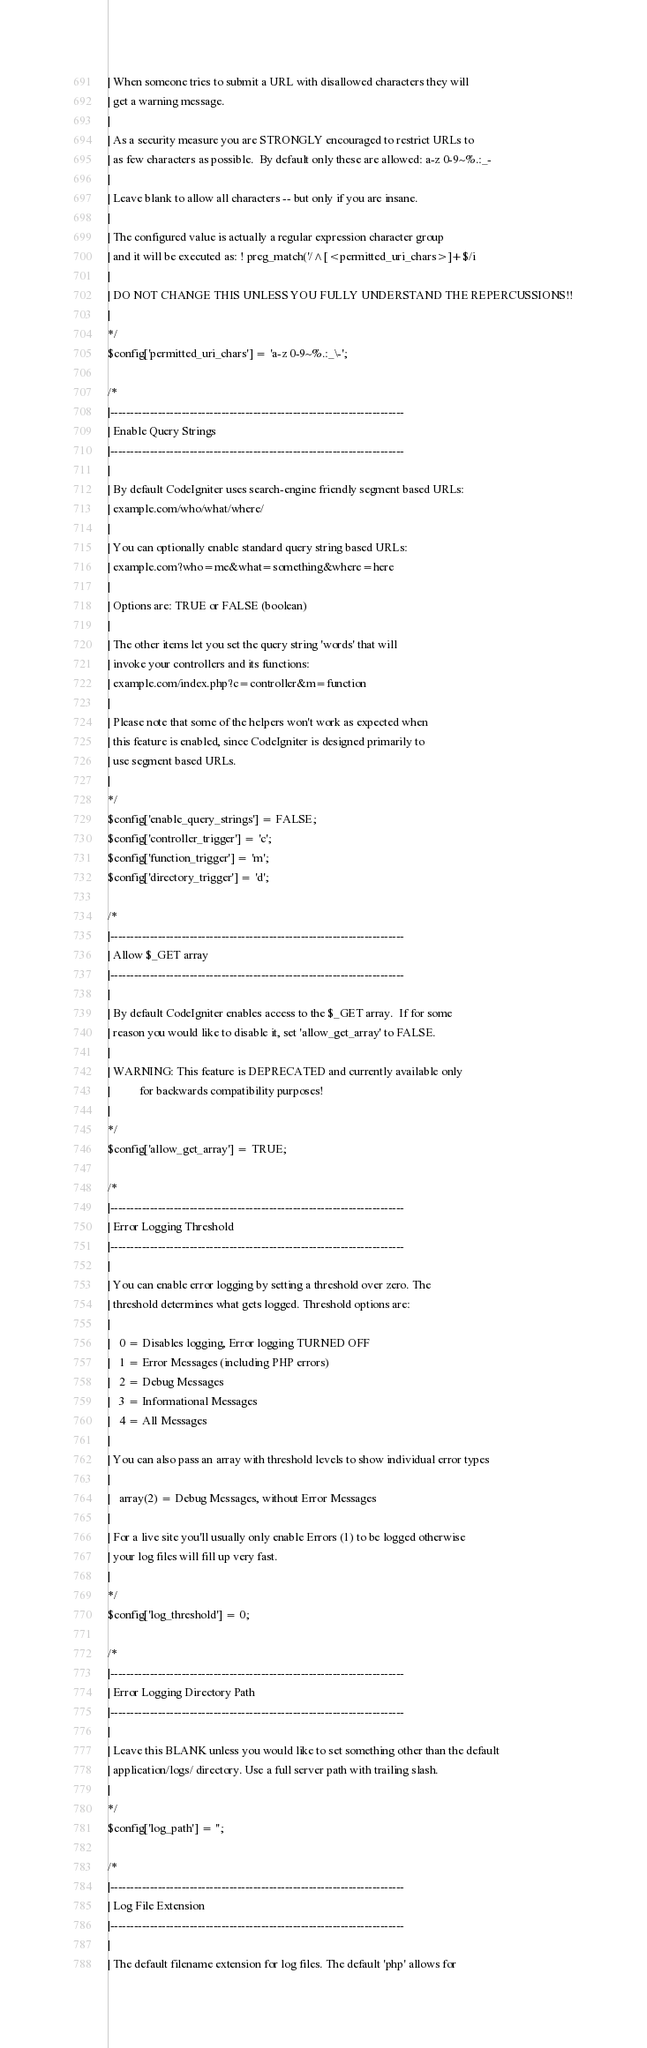Convert code to text. <code><loc_0><loc_0><loc_500><loc_500><_PHP_>| When someone tries to submit a URL with disallowed characters they will
| get a warning message.
|
| As a security measure you are STRONGLY encouraged to restrict URLs to
| as few characters as possible.  By default only these are allowed: a-z 0-9~%.:_-
|
| Leave blank to allow all characters -- but only if you are insane.
|
| The configured value is actually a regular expression character group
| and it will be executed as: ! preg_match('/^[<permitted_uri_chars>]+$/i
|
| DO NOT CHANGE THIS UNLESS YOU FULLY UNDERSTAND THE REPERCUSSIONS!!
|
*/
$config['permitted_uri_chars'] = 'a-z 0-9~%.:_\-';

/*
|--------------------------------------------------------------------------
| Enable Query Strings
|--------------------------------------------------------------------------
|
| By default CodeIgniter uses search-engine friendly segment based URLs:
| example.com/who/what/where/
|
| You can optionally enable standard query string based URLs:
| example.com?who=me&what=something&where=here
|
| Options are: TRUE or FALSE (boolean)
|
| The other items let you set the query string 'words' that will
| invoke your controllers and its functions:
| example.com/index.php?c=controller&m=function
|
| Please note that some of the helpers won't work as expected when
| this feature is enabled, since CodeIgniter is designed primarily to
| use segment based URLs.
|
*/
$config['enable_query_strings'] = FALSE;
$config['controller_trigger'] = 'c';
$config['function_trigger'] = 'm';
$config['directory_trigger'] = 'd';

/*
|--------------------------------------------------------------------------
| Allow $_GET array
|--------------------------------------------------------------------------
|
| By default CodeIgniter enables access to the $_GET array.  If for some
| reason you would like to disable it, set 'allow_get_array' to FALSE.
|
| WARNING: This feature is DEPRECATED and currently available only
|          for backwards compatibility purposes!
|
*/
$config['allow_get_array'] = TRUE;

/*
|--------------------------------------------------------------------------
| Error Logging Threshold
|--------------------------------------------------------------------------
|
| You can enable error logging by setting a threshold over zero. The
| threshold determines what gets logged. Threshold options are:
|
|	0 = Disables logging, Error logging TURNED OFF
|	1 = Error Messages (including PHP errors)
|	2 = Debug Messages
|	3 = Informational Messages
|	4 = All Messages
|
| You can also pass an array with threshold levels to show individual error types
|
| 	array(2) = Debug Messages, without Error Messages
|
| For a live site you'll usually only enable Errors (1) to be logged otherwise
| your log files will fill up very fast.
|
*/
$config['log_threshold'] = 0;

/*
|--------------------------------------------------------------------------
| Error Logging Directory Path
|--------------------------------------------------------------------------
|
| Leave this BLANK unless you would like to set something other than the default
| application/logs/ directory. Use a full server path with trailing slash.
|
*/
$config['log_path'] = '';

/*
|--------------------------------------------------------------------------
| Log File Extension
|--------------------------------------------------------------------------
|
| The default filename extension for log files. The default 'php' allows for</code> 